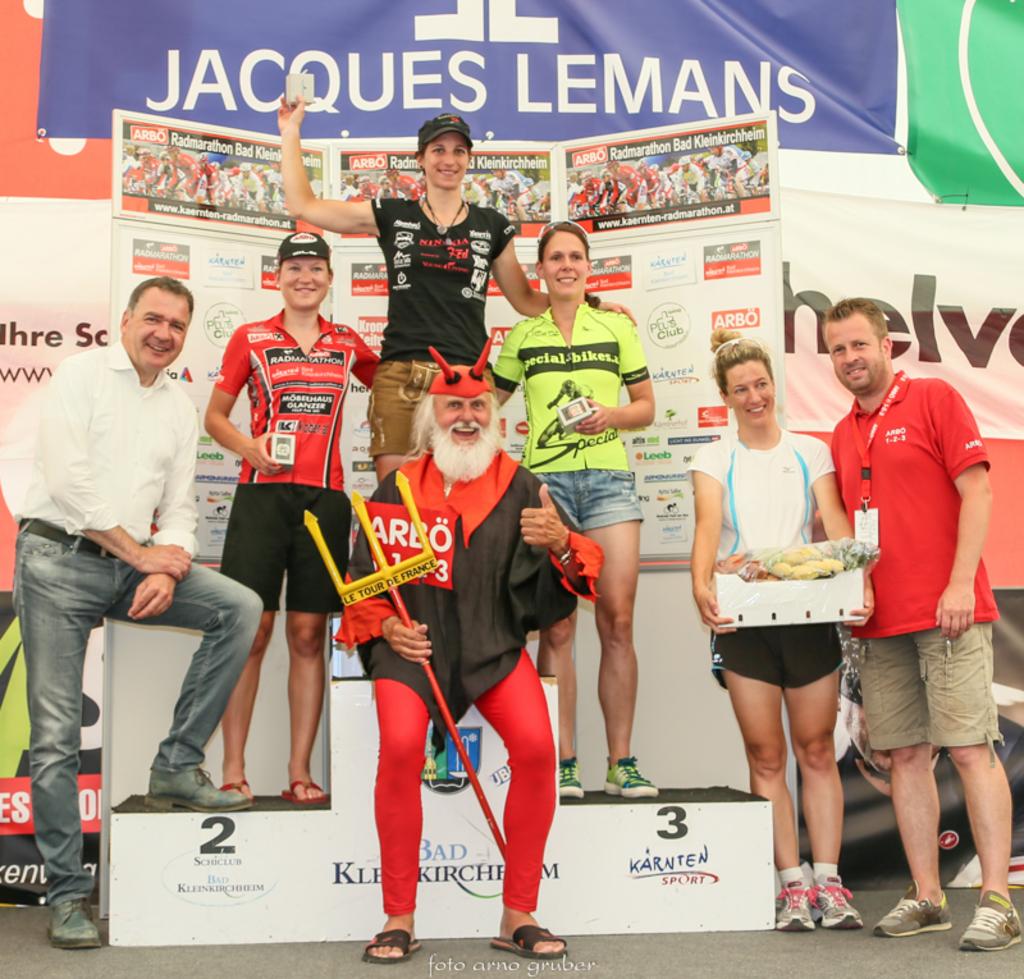Who sponsored this event?
Provide a short and direct response. Jacques lemans. What number is on the right side of the podium?
Give a very brief answer. 3. 